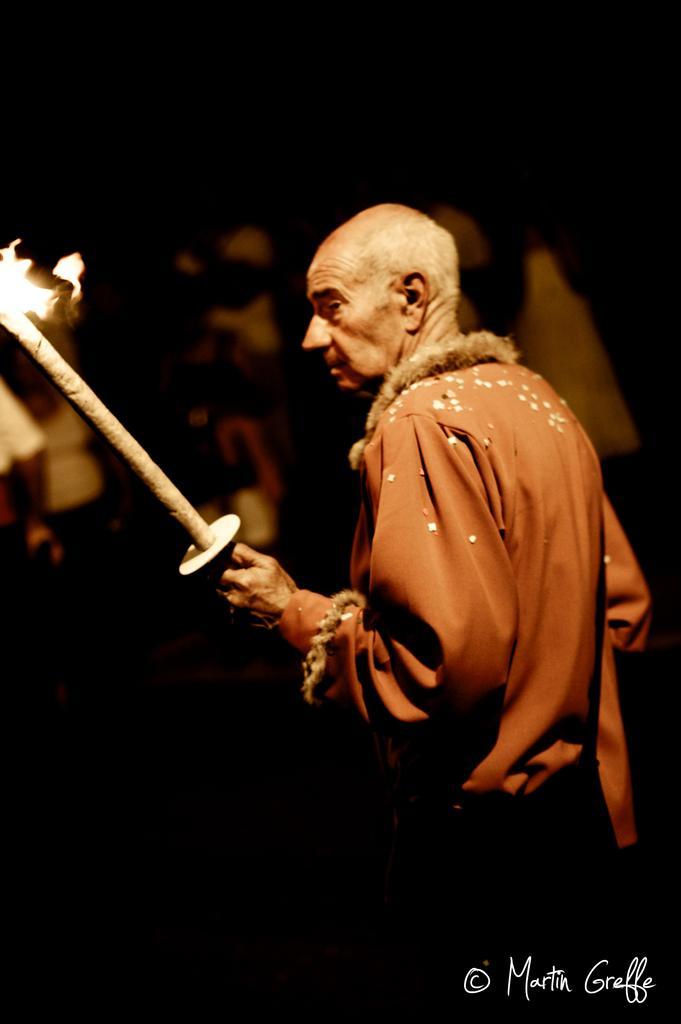In one or two sentences, can you explain what this image depicts? In this image, we can see a person wearing clothes and holding a firestick with his hand. There is a text in the bottom right of the image. 